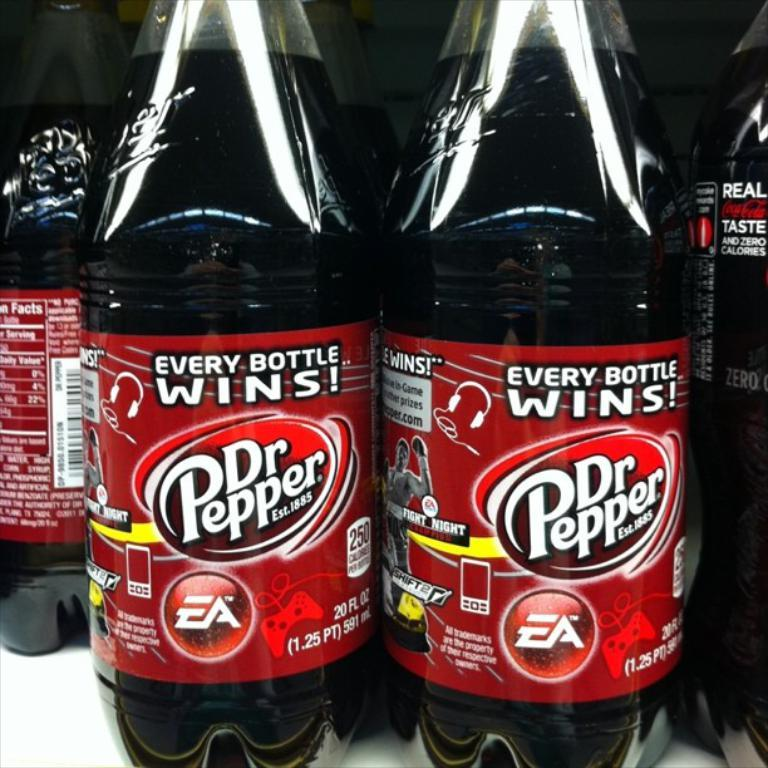What type of bottles are present in the image? The image contains preservative drinking bottles. Can you describe the bottles in more detail? The bottles are designed for preserving and storing liquids, such as drinks. What type of ocean can be seen in the background of the image? There is no ocean present in the image; it only contains preservative drinking bottles. 